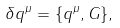Convert formula to latex. <formula><loc_0><loc_0><loc_500><loc_500>\delta q ^ { \mu } = \{ q ^ { \mu } , G \} ,</formula> 